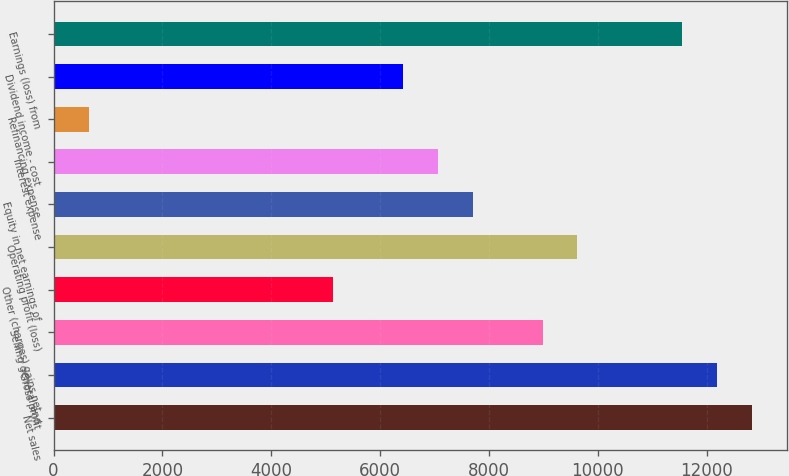Convert chart to OTSL. <chart><loc_0><loc_0><loc_500><loc_500><bar_chart><fcel>Net sales<fcel>Gross profit<fcel>Selling general and<fcel>Other (charges) gains net<fcel>Operating profit (loss)<fcel>Equity in net earnings of<fcel>Interest expense<fcel>Refinancing expense<fcel>Dividend income - cost<fcel>Earnings (loss) from<nl><fcel>12834<fcel>12192.4<fcel>8984.4<fcel>5134.8<fcel>9626<fcel>7701.2<fcel>7059.6<fcel>643.6<fcel>6418<fcel>11550.8<nl></chart> 